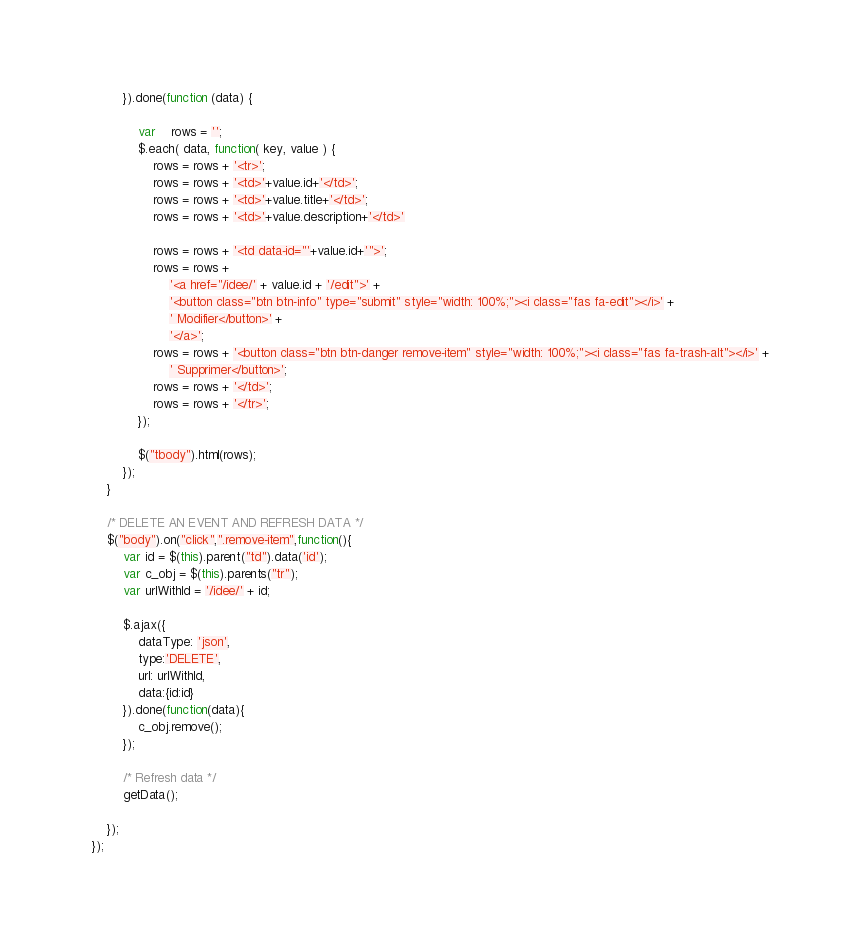Convert code to text. <code><loc_0><loc_0><loc_500><loc_500><_JavaScript_>        }).done(function (data) {

            var	rows = '';
            $.each( data, function( key, value ) {
                rows = rows + '<tr>';
                rows = rows + '<td>'+value.id+'</td>';
                rows = rows + '<td>'+value.title+'</td>';
                rows = rows + '<td>'+value.description+'</td>'

                rows = rows + '<td data-id="'+value.id+'">';
                rows = rows +
                    '<a href="/idee/' + value.id + '/edit">' +
                    '<button class="btn btn-info" type="submit" style="width: 100%;"><i class="fas fa-edit"></i>' +
                    ' Modifier</button>' +
                    '</a>';
                rows = rows + '<button class="btn btn-danger remove-item" style="width: 100%;"><i class="fas fa-trash-alt"></i>' +
                    ' Supprimer</button>';
                rows = rows + '</td>';
                rows = rows + '</tr>';
            });

            $("tbody").html(rows);
        });
    }

    /* DELETE AN EVENT AND REFRESH DATA */
    $("body").on("click",".remove-item",function(){
        var id = $(this).parent("td").data('id');
        var c_obj = $(this).parents("tr");
        var urlWithId = '/idee/' + id;

        $.ajax({
            dataType: 'json',
            type:'DELETE',
            url: urlWithId,
            data:{id:id}
        }).done(function(data){
            c_obj.remove();
        });

        /* Refresh data */
        getData();

    });
});</code> 